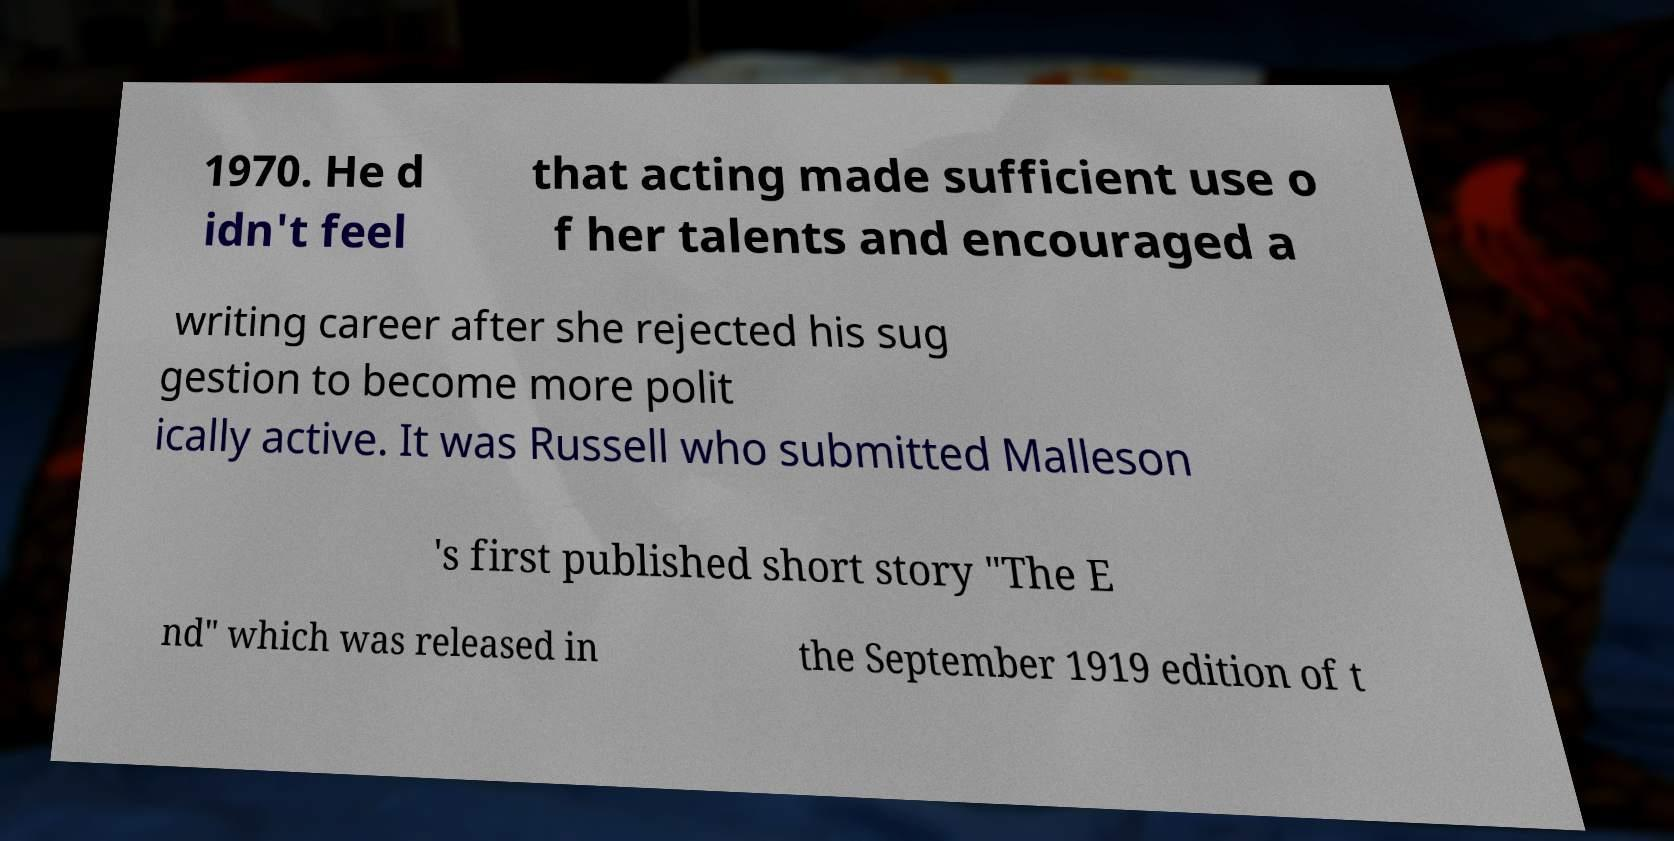Can you accurately transcribe the text from the provided image for me? 1970. He d idn't feel that acting made sufficient use o f her talents and encouraged a writing career after she rejected his sug gestion to become more polit ically active. It was Russell who submitted Malleson 's first published short story "The E nd" which was released in the September 1919 edition of t 